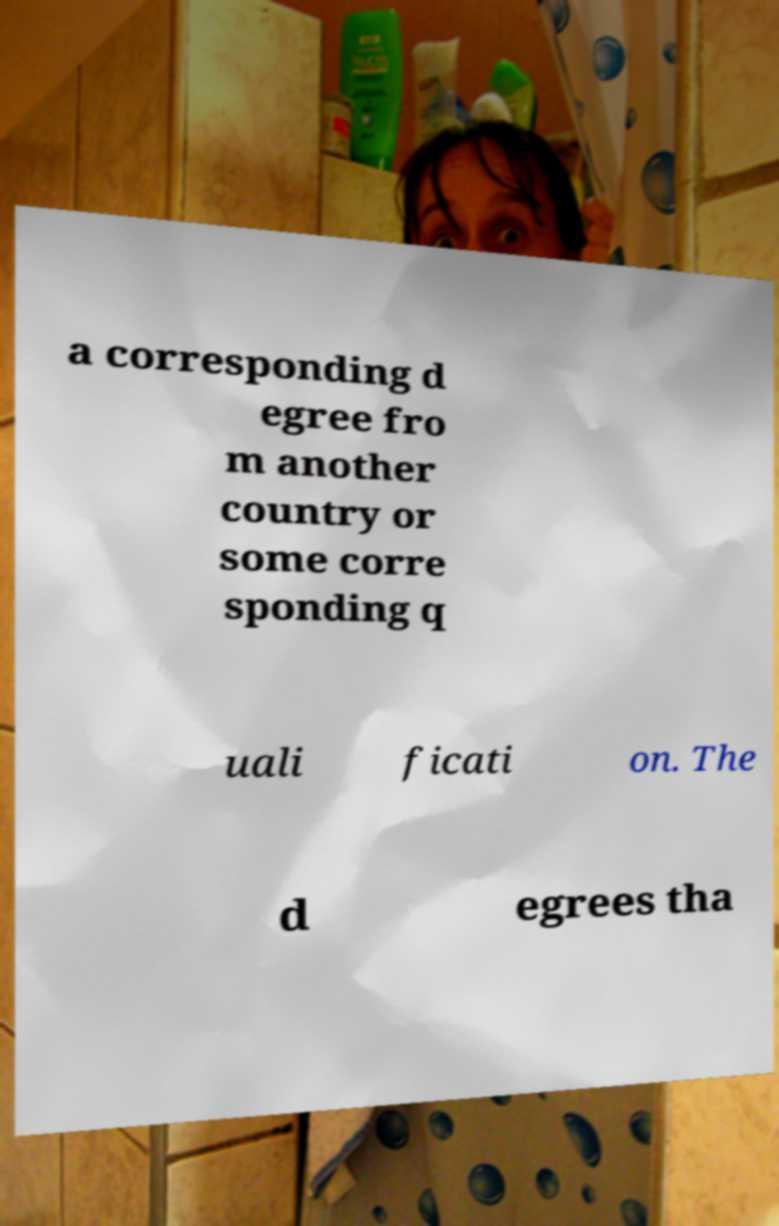Could you assist in decoding the text presented in this image and type it out clearly? a corresponding d egree fro m another country or some corre sponding q uali ficati on. The d egrees tha 